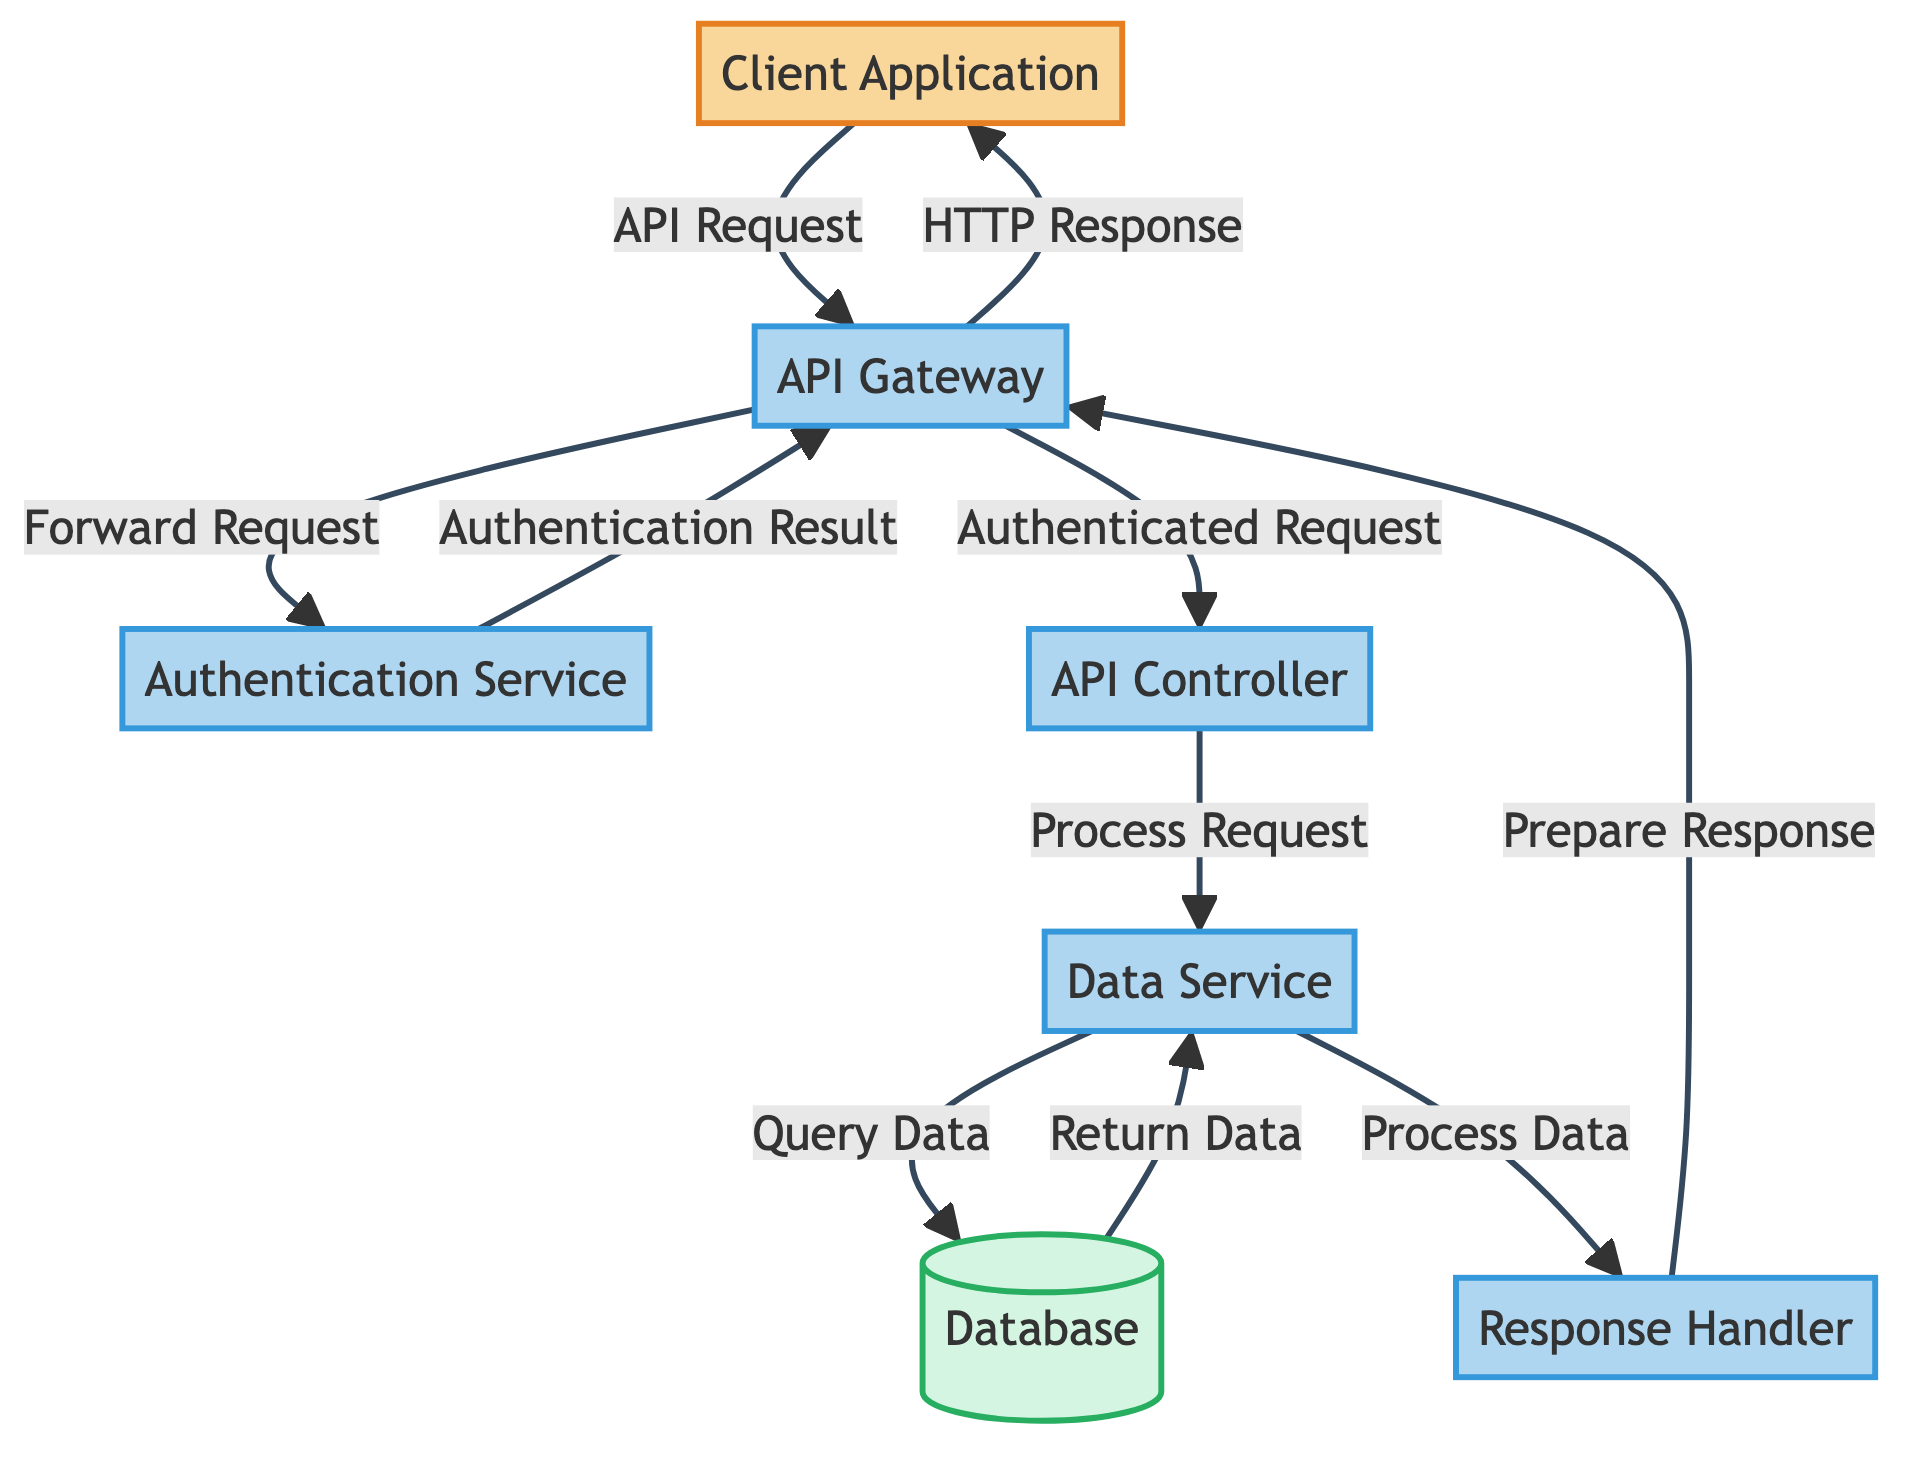What is the first component in the API request flow? The first component to receive the API request is the Client Application. This is determined by the arrow pointing from the client to the API Gateway, indicating the direction of the request flow.
Answer: Client Application How many processes are there in the diagram? The diagram contains six processes: API Gateway, Authentication Service, API Controller, Data Service, Response Handler, and Query Data. Counting each labeled process node gives a total of six.
Answer: Six What does the API Gateway do after receiving a request? After receiving a request, the API Gateway forwards the request to the Authentication Service. This is shown by the arrow leading from the API Gateway to the Authentication Service labeled "Forward Request."
Answer: Forwards the request Which component returns the data to the Data Service? The database returns data to the Data Service. This relationship is illustrated by the arrow labeled "Return Data" flowing from the database to the Data Service.
Answer: Database What is the last step before sending an HTTP response back to the client? The last step before sending an HTTP response is preparing the response in the Response Handler. This can be seen as the final process where data is formatted before it is sent back.
Answer: Prepare Response How does the API Gateway respond to the client? The API Gateway responds to the client by sending an HTTP Response. This is shown by the arrow leading from the API Gateway towards the Client Application labeled "HTTP Response."
Answer: HTTP Response What component performs authentication in this diagram? The component that performs authentication is the Authentication Service, as indicated by the explicit labeling in the diagram and the flow of requests surrounding it.
Answer: Authentication Service Which two components are directly connected in a processing step after authentication? After authentication, the API Gateway and API Controller are directly connected in a processing step where the API Gateway forwards the authenticated request to the API Controller. This is indicated by the arrow labeled "Authenticated Request."
Answer: API Gateway and API Controller 